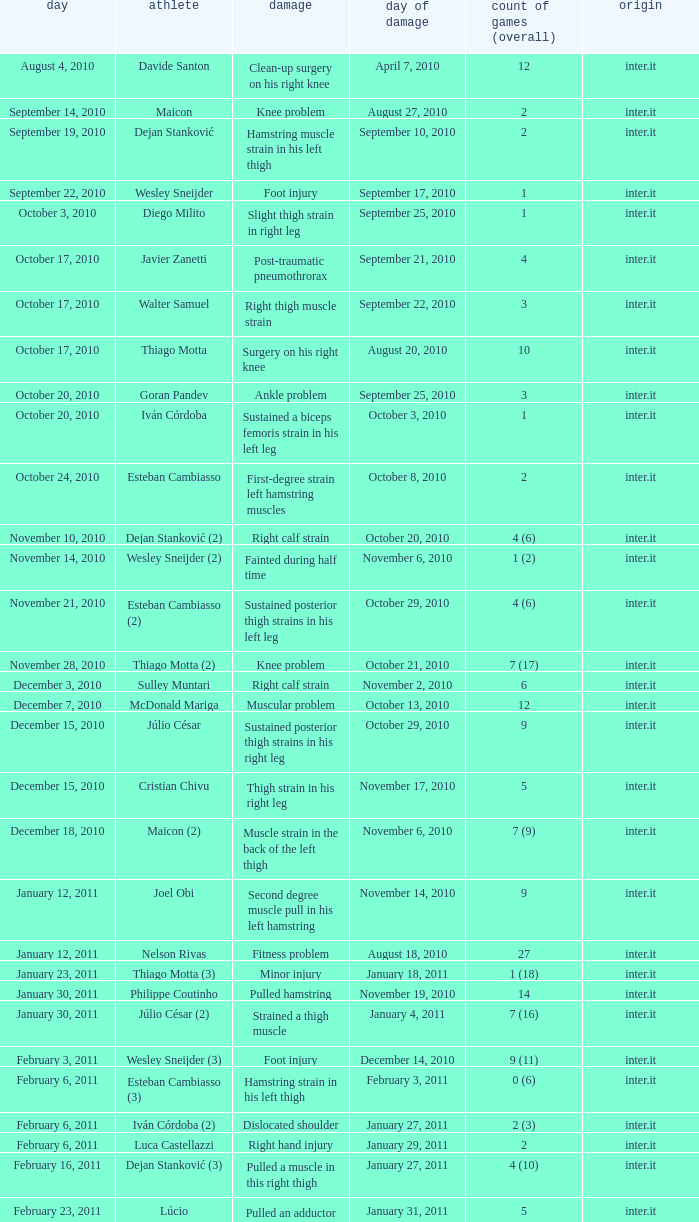What is the date of injury for player Wesley sneijder (2)? November 6, 2010. 